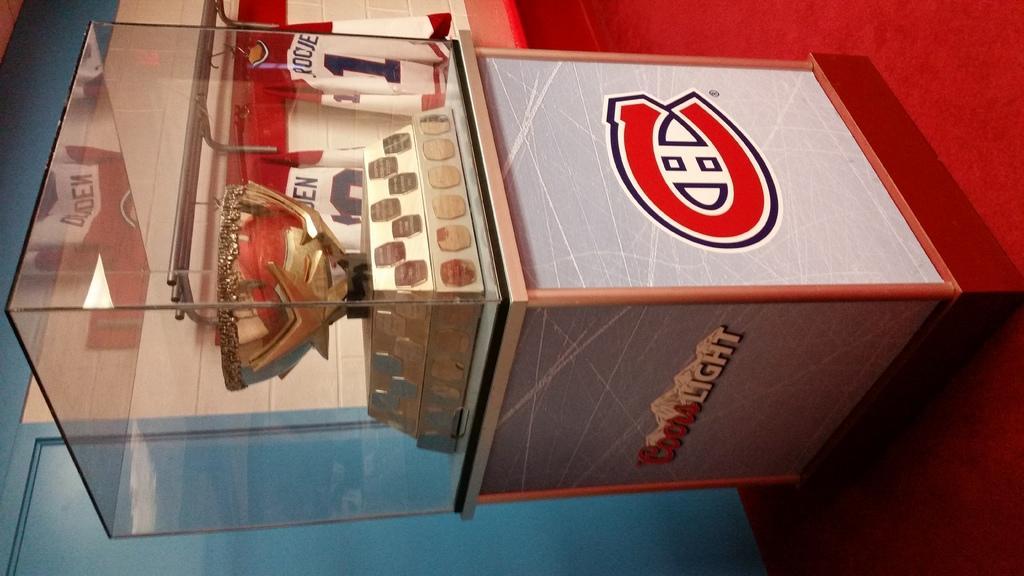Describe this image in one or two sentences. In this picture we can see a cup in a glass. There is a red carpet on the path. A wall is visible in the background. 